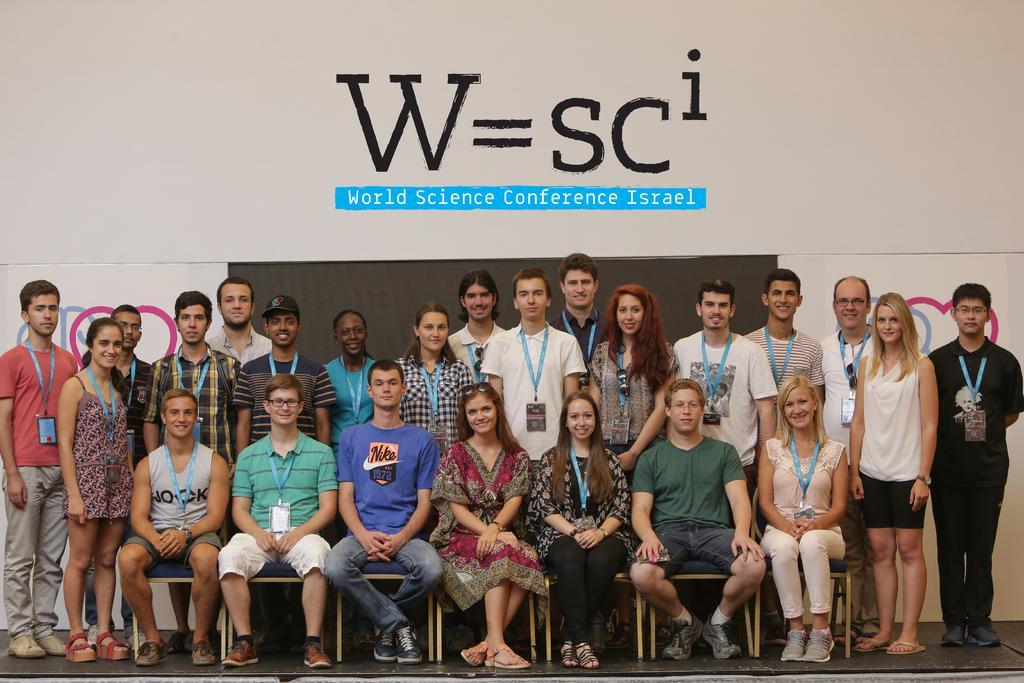Describe this image in one or two sentences. In the center of the image we can see a few people are sitting on the chairs and few people are standing. And we can see they are smiling, which we can see on their faces. In the background there is a wall, banners, black board and a few other objects. 